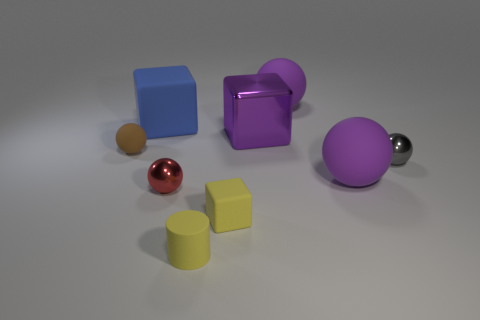What number of things are either balls that are in front of the brown matte ball or purple metallic objects?
Keep it short and to the point. 4. What shape is the big purple rubber thing that is behind the rubber thing that is to the left of the large blue thing?
Your response must be concise. Sphere. There is a tiny yellow object that is in front of the tiny yellow matte cube; is its shape the same as the tiny gray thing?
Your answer should be compact. No. There is a small shiny ball that is on the right side of the tiny cylinder; what is its color?
Ensure brevity in your answer.  Gray. What number of balls are large blue matte things or gray metallic things?
Provide a succinct answer. 1. What size is the rubber cylinder on the right side of the shiny ball that is to the left of the purple cube?
Keep it short and to the point. Small. Does the small cylinder have the same color as the small metal object left of the yellow cylinder?
Your answer should be compact. No. There is a tiny yellow matte cylinder; how many small blocks are on the right side of it?
Your response must be concise. 1. Are there fewer small gray metallic balls than small metallic things?
Provide a short and direct response. Yes. There is a block that is both right of the big blue rubber block and behind the brown matte ball; what is its size?
Keep it short and to the point. Large. 